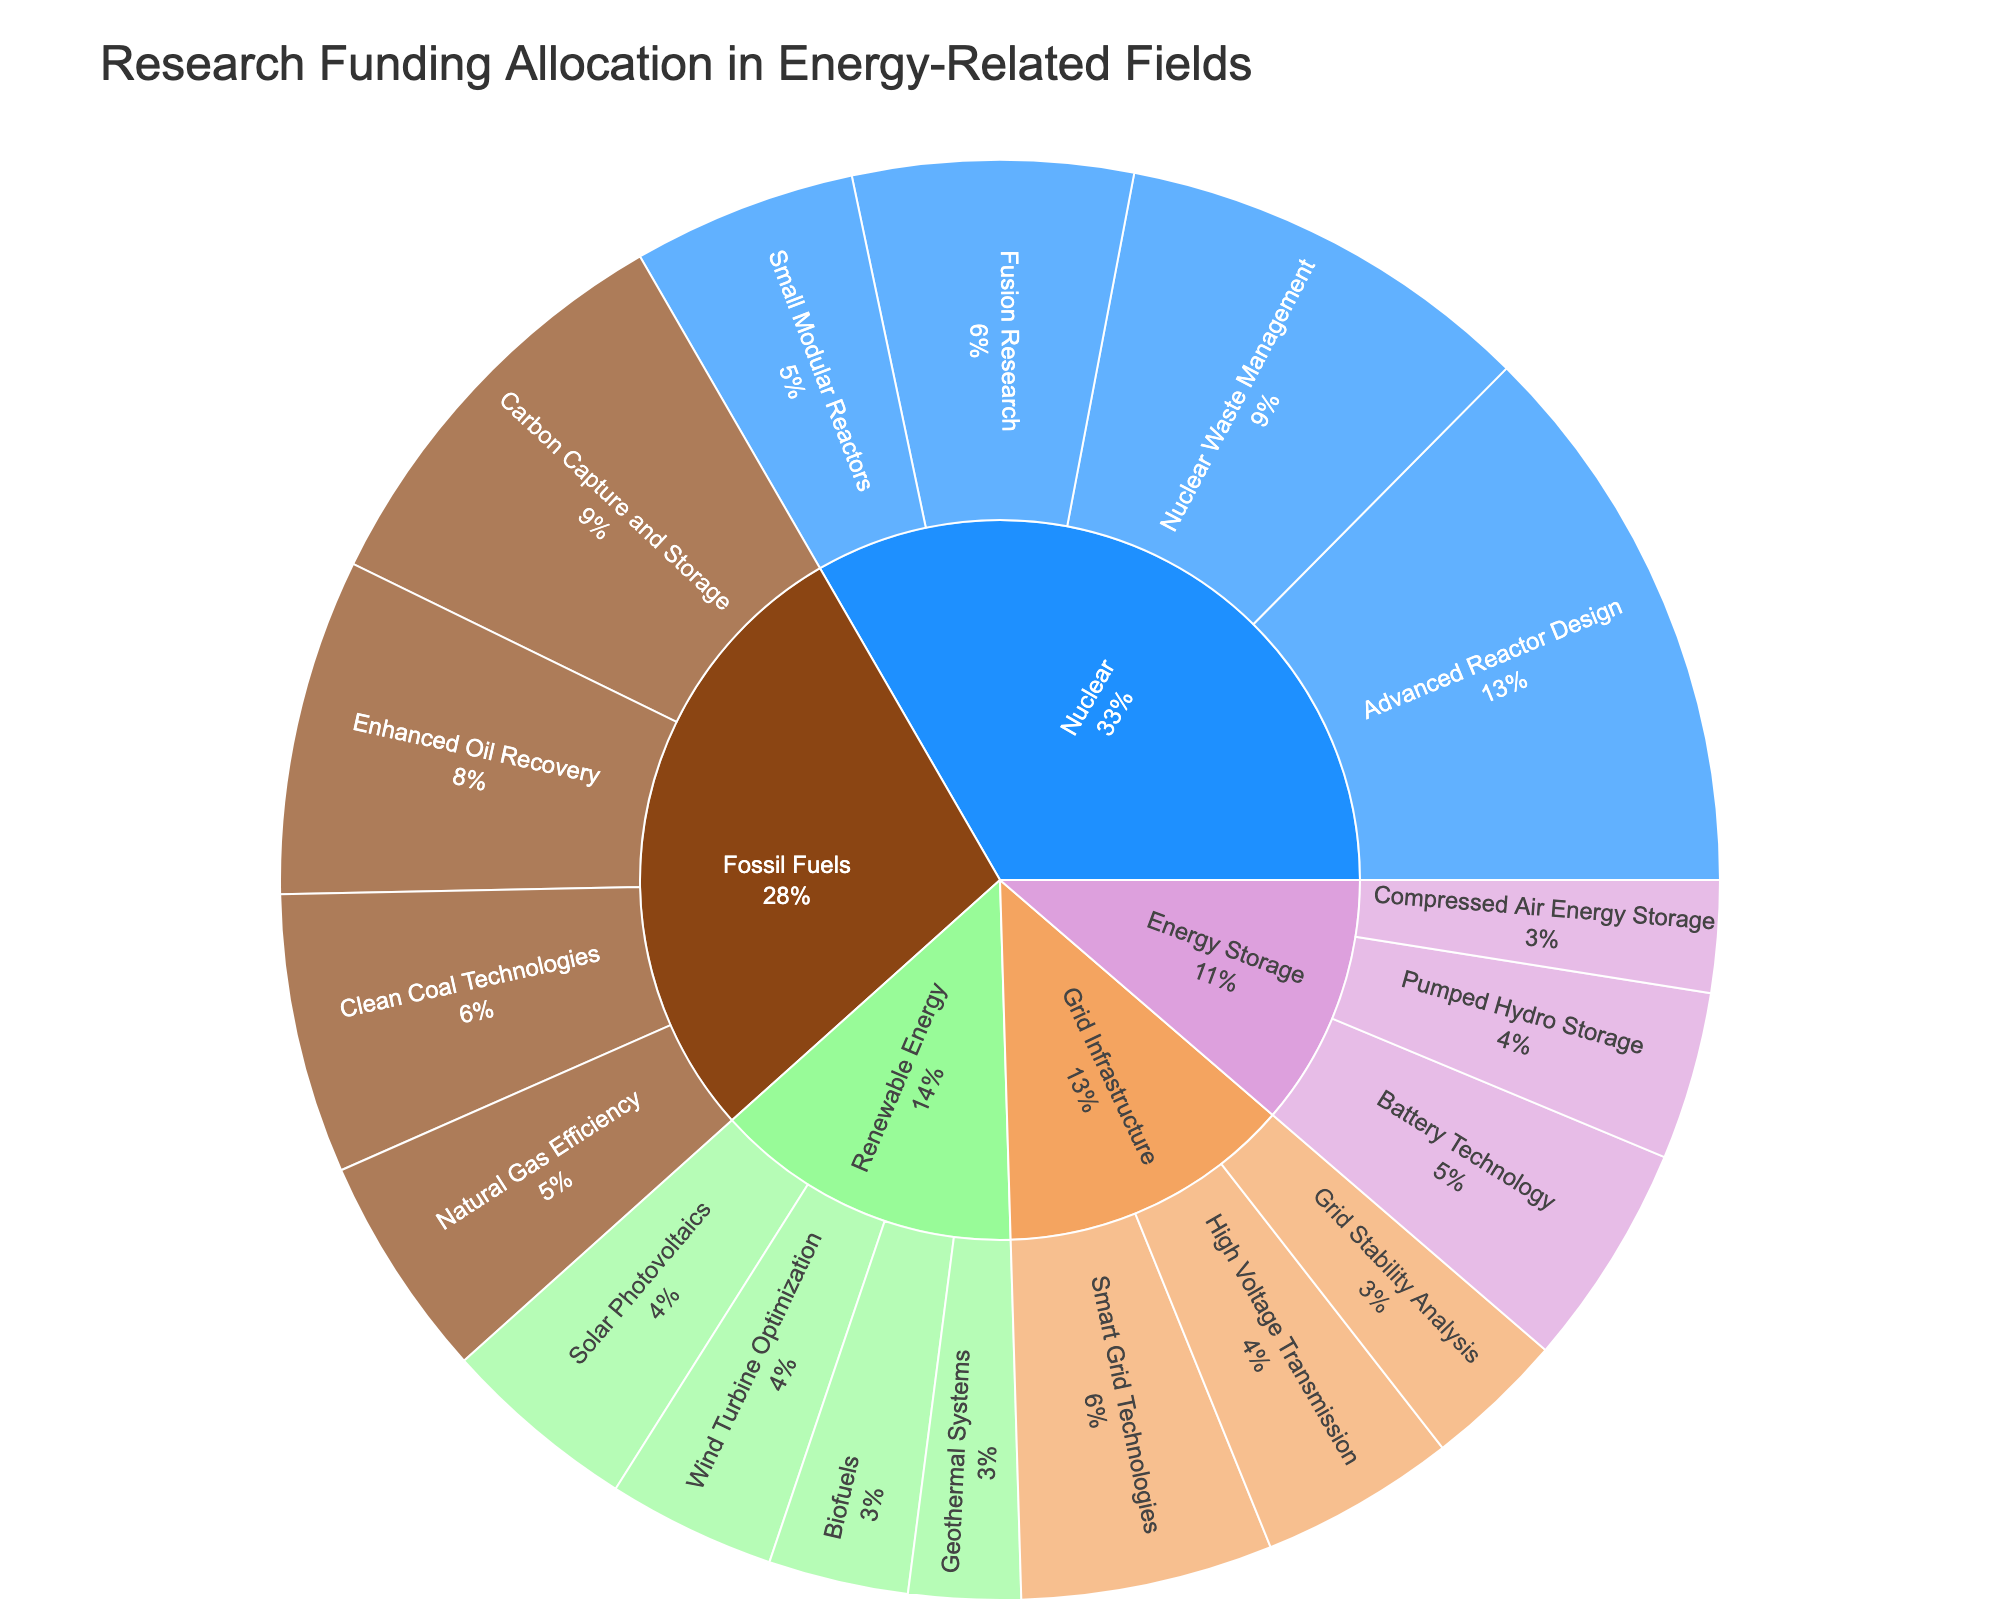Which energy source received the highest funding allocation? The figure shows various energy sources with their respective funding allocations. By examining the segments, we can see that the "Nuclear" energy source has the largest segment.
Answer: Nuclear Which research area within Fossil Fuels received the most funding? By inspecting the segments under the "Fossil Fuels" category, we identify the "Carbon Capture and Storage" segment as the largest sub-segment.
Answer: Carbon Capture and Storage What is the total funding allocated to Renewable Energy research? Adding the funding allocations for each research area within the "Renewable Energy" category: Solar Photovoltaics ($70M) + Wind Turbine Optimization ($60M) + Biofuels ($50M) + Geothermal Systems ($40M) = $220M.
Answer: $220M How does the funding for Battery Technology compare to Clean Coal Technologies? The figure provides the funding amounts for both "Battery Technology" ($80M) and "Clean Coal Technologies" ($100M). Comparing the two, we see that Clean Coal Technologies received $20M more.
Answer: Clean Coal Technologies received $20M more Which research area received the least funding, and how much was it? The figure shows various funding amounts. The smallest segment corresponds to "Geothermal Systems" within Renewable Energy, which received $40M.
Answer: Geothermal Systems, $40M What's the average funding allocation for research areas within Grid Infrastructure? The figure provides funding allocations for three research areas under "Grid Infrastructure". Summing these (Smart Grid Technologies: $90M, High Voltage Transmission: $70M, Grid Stability Analysis: $50M) gives a total of $210M. Dividing by the three areas: $210M / 3 = $70M.
Answer: $70M Compare the total funding for Nuclear to Fossil Fuels. Which received more, and by how much? Summing the Nuclear research areas (Advanced Reactor Design: $200M, Nuclear Waste Management: $150M, Fusion Research: $100M, Small Modular Reactors: $80M) gives a total of $530M. Summing the Fossil Fuels areas (Carbon Capture and Storage: $150M, Enhanced Oil Recovery: $120M, Clean Coal Technologies: $100M, Natural Gas Efficiency: $80M) gives a total of $450M. Nuclear received more by $530M - $450M = $80M.
Answer: Nuclear received $80M more Identify the funding allocation for research areas within Energy Storage and determine the percentage share of each area. Summing the funding for Energy Storage (Battery Technology: $80M, Pumped Hydro Storage: $60M, Compressed Air Energy Storage: $40M) gives a total of $180M. Calculating the percentages: Battery Technology: ($80M / $180M) * 100 ≈ 44.44%, Pumped Hydro Storage: ($60M / $180M) * 100 ≈ 33.33%, Compressed Air Energy Storage: ($40M / $180M) * 100 ≈ 22.22%.
Answer: Battery Technology: 44.44%, Pumped Hydro Storage: 33.33%, Compressed Air Energy Storage: 22.22% How does the funding for Natural Gas Efficiency compare to High Voltage Transmission in absolute terms? The figure shows the funding amounts for "Natural Gas Efficiency" ($80M) and "High Voltage Transmission" ($70M). The absolute difference is $80M - $70M = $10M.
Answer: Natural Gas Efficiency is $10M more What proportion of the overall funding is allocated to Fossil Fuels compared to the total funding for all sources? Summing the total funding for all sources in the figure gives Fossil Fuels ($450M) + Nuclear ($530M) + Renewable Energy ($220M) + Energy Storage ($180M) + Grid Infrastructure ($210M) = $1590M. The proportion for Fossil Fuels is ($450M / $1590M) * 100 ≈ 28.30%.
Answer: Approximately 28.30% 